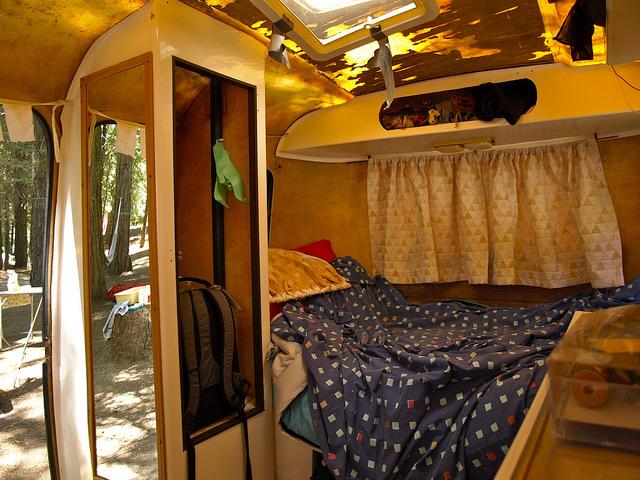Is there a backpack in this picture?
Short answer required. Yes. Is it sunny out?
Be succinct. Yes. Is this a good place to sleep when camping?
Write a very short answer. Yes. 